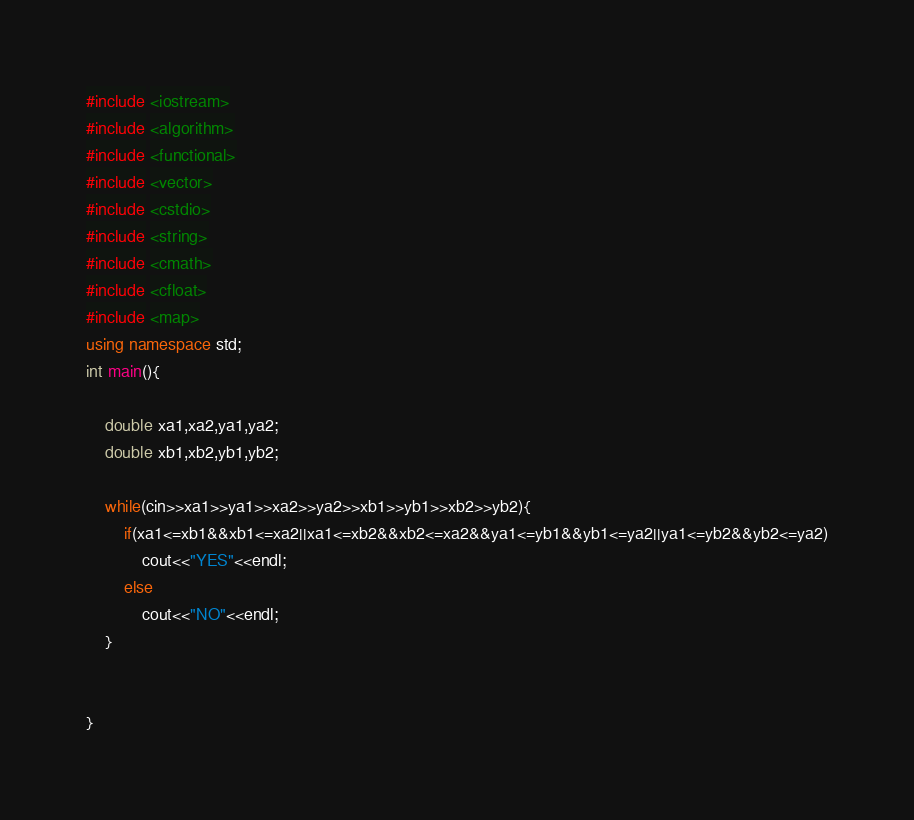Convert code to text. <code><loc_0><loc_0><loc_500><loc_500><_C++_>#include <iostream>
#include <algorithm>
#include <functional>
#include <vector>
#include <cstdio>
#include <string>
#include <cmath>
#include <cfloat>
#include <map>
using namespace std;
int main(){
	
	double xa1,xa2,ya1,ya2;
	double xb1,xb2,yb1,yb2;
	
	while(cin>>xa1>>ya1>>xa2>>ya2>>xb1>>yb1>>xb2>>yb2){
		if(xa1<=xb1&&xb1<=xa2||xa1<=xb2&&xb2<=xa2&&ya1<=yb1&&yb1<=ya2||ya1<=yb2&&yb2<=ya2)
			cout<<"YES"<<endl;
		else
			cout<<"NO"<<endl;
	}
	
	
}</code> 